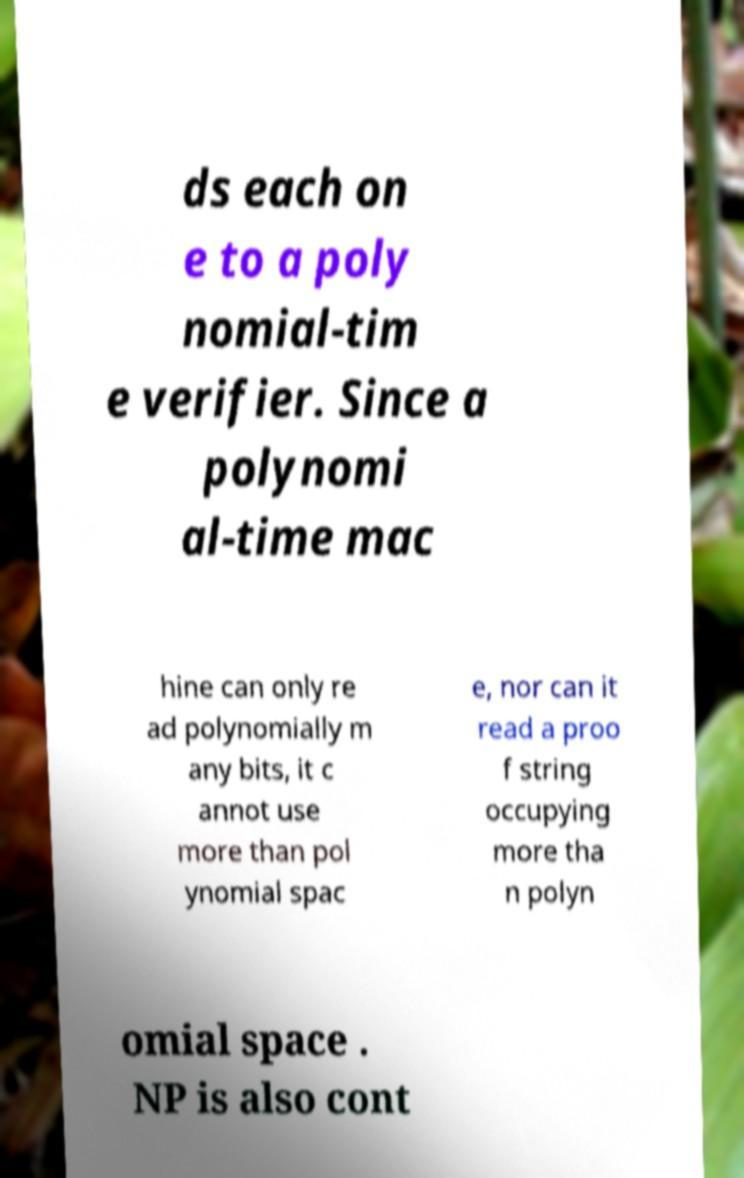Can you read and provide the text displayed in the image?This photo seems to have some interesting text. Can you extract and type it out for me? ds each on e to a poly nomial-tim e verifier. Since a polynomi al-time mac hine can only re ad polynomially m any bits, it c annot use more than pol ynomial spac e, nor can it read a proo f string occupying more tha n polyn omial space . NP is also cont 